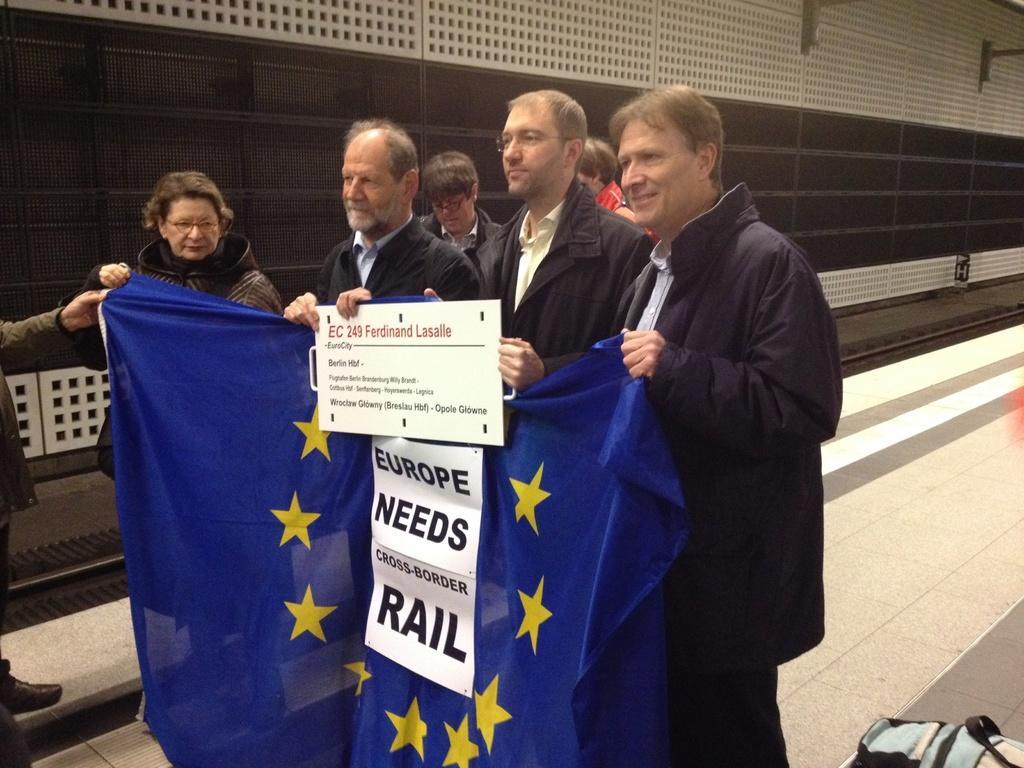How would you summarize this image in a sentence or two? In this picture we can see a group of people are standing on the path and some people are holding the board and blue flag. Behind the people there is a wall. 